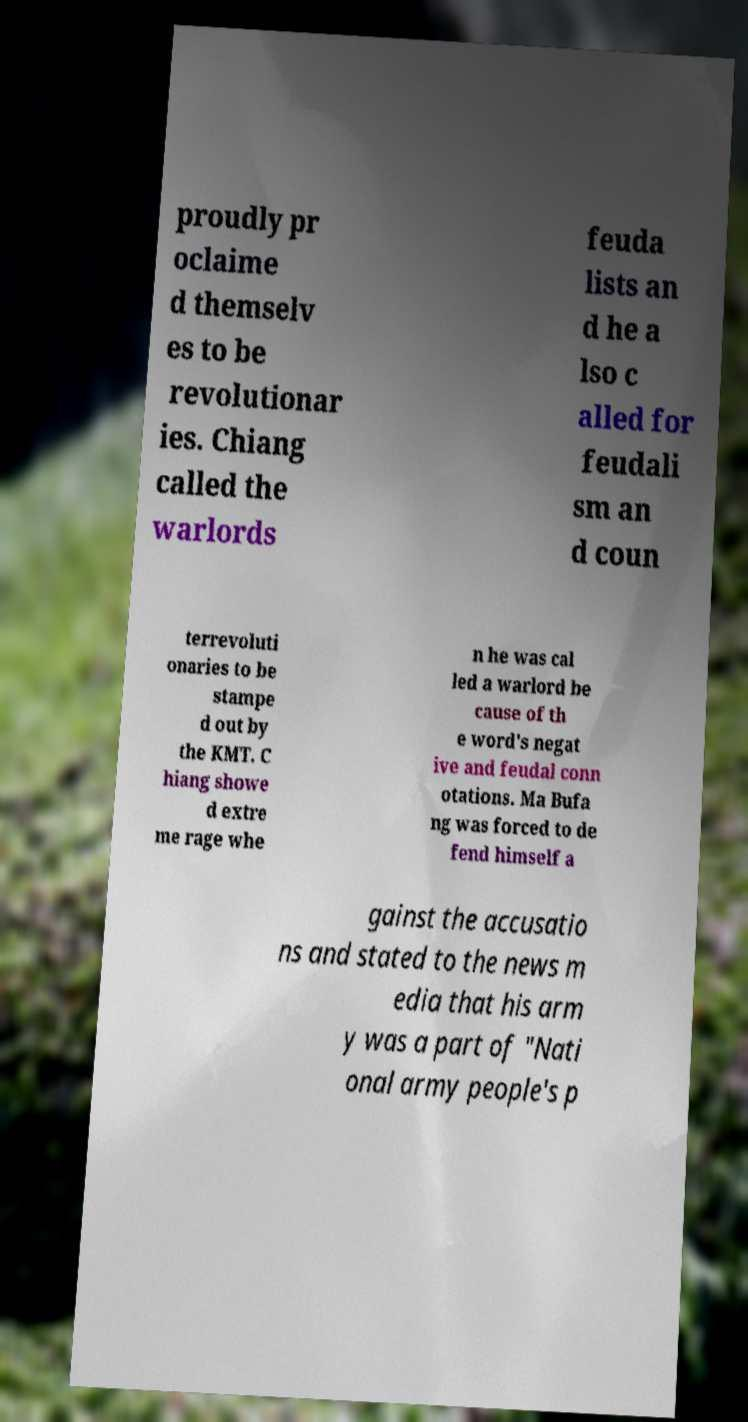I need the written content from this picture converted into text. Can you do that? proudly pr oclaime d themselv es to be revolutionar ies. Chiang called the warlords feuda lists an d he a lso c alled for feudali sm an d coun terrevoluti onaries to be stampe d out by the KMT. C hiang showe d extre me rage whe n he was cal led a warlord be cause of th e word's negat ive and feudal conn otations. Ma Bufa ng was forced to de fend himself a gainst the accusatio ns and stated to the news m edia that his arm y was a part of "Nati onal army people's p 